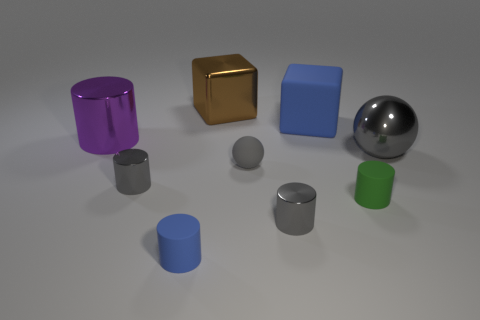Does the big blue thing have the same shape as the green thing? No, the big blue object is a cube while the green one is a cylinder. Despite their color difference, it's their shapes that are distinct; a cube has six square faces, edges, and vertices making it a polyhedron, whereas a cylinder is curved with two circular faces at the ends and a curved side. 